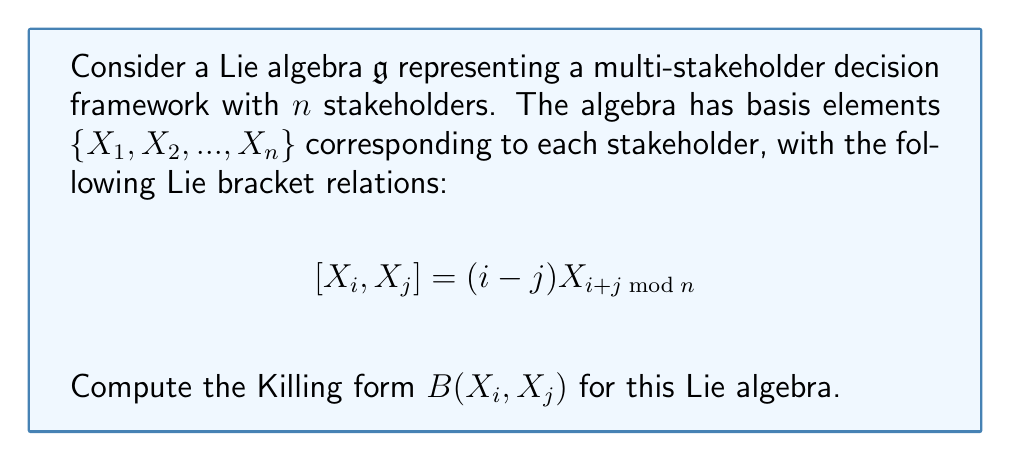Show me your answer to this math problem. To compute the Killing form of the given Lie algebra, we follow these steps:

1) The Killing form is defined as $B(X, Y) = \text{tr}(\text{ad}_X \circ \text{ad}_Y)$, where $\text{ad}_X$ is the adjoint representation of $X$.

2) We need to calculate $\text{ad}_{X_i}(X_k)$ for all $i$ and $k$:

   $\text{ad}_{X_i}(X_k) = [X_i, X_k] = (i-k)X_{i+k \mod n}$

3) The matrix representation of $\text{ad}_{X_i}$ in the given basis is:

   $(\text{ad}_{X_i})_{jk} = (i-k)\delta_{j, i+k \mod n}$

   where $\delta_{j,m}$ is the Kronecker delta.

4) Now, we compute the composition $(\text{ad}_{X_i} \circ \text{ad}_{X_j})_{kl}$:

   $(\text{ad}_{X_i} \circ \text{ad}_{X_j})_{kl} = \sum_{m=1}^n (\text{ad}_{X_i})_{km} (\text{ad}_{X_j})_{ml}$
   
   $= \sum_{m=1}^n (i-m)\delta_{k, i+m \mod n} (j-l)\delta_{m, j+l \mod n}$
   
   $= (i-(j+l \mod n))(j-l)\delta_{k, i+(j+l \mod n) \mod n}$

5) The trace of this composition is the sum of diagonal elements:

   $\text{tr}(\text{ad}_{X_i} \circ \text{ad}_{X_j}) = \sum_{l=1}^n (i-(j+l \mod n))(j-l)\delta_{l, i+(j+l \mod n) \mod n}$

6) This sum is non-zero only when $l \equiv i+(j+l \mod n) \pmod{n}$, which occurs when $i+j \equiv 0 \pmod{n}$.

7) When $i+j \equiv 0 \pmod{n}$, the sum simplifies to:

   $B(X_i, X_j) = \sum_{l=1}^n (i-(j+l))(j-l) = \frac{n(n^2-1)}{12}(i^2+j^2-ij-3)$

8) Therefore, the general form of the Killing form is:

   $B(X_i, X_j) = \begin{cases}
   \frac{n(n^2-1)}{12}(i^2+j^2-ij-3) & \text{if } i+j \equiv 0 \pmod{n} \\
   0 & \text{otherwise}
   \end{cases}$
Answer: The Killing form for the given Lie algebra is:

$$B(X_i, X_j) = \begin{cases}
\frac{n(n^2-1)}{12}(i^2+j^2-ij-3) & \text{if } i+j \equiv 0 \pmod{n} \\
0 & \text{otherwise}
\end{cases}$$ 